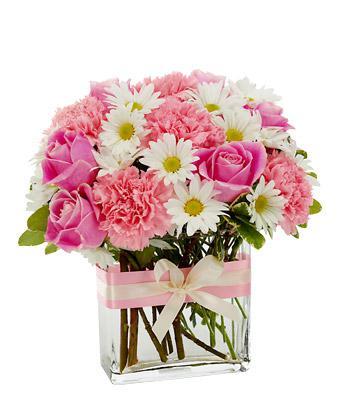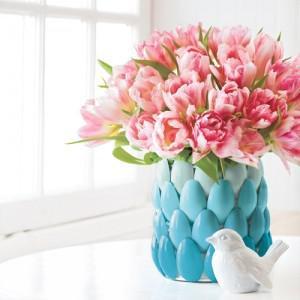The first image is the image on the left, the second image is the image on the right. Examine the images to the left and right. Is the description "The left image features a clear vase containing several pink roses and one orange one, and the vase has a solid-colored flower on its front." accurate? Answer yes or no. No. The first image is the image on the left, the second image is the image on the right. Analyze the images presented: Is the assertion "One of the images shows a vase of flowers with one single flower attached to the outside of the vase." valid? Answer yes or no. No. 